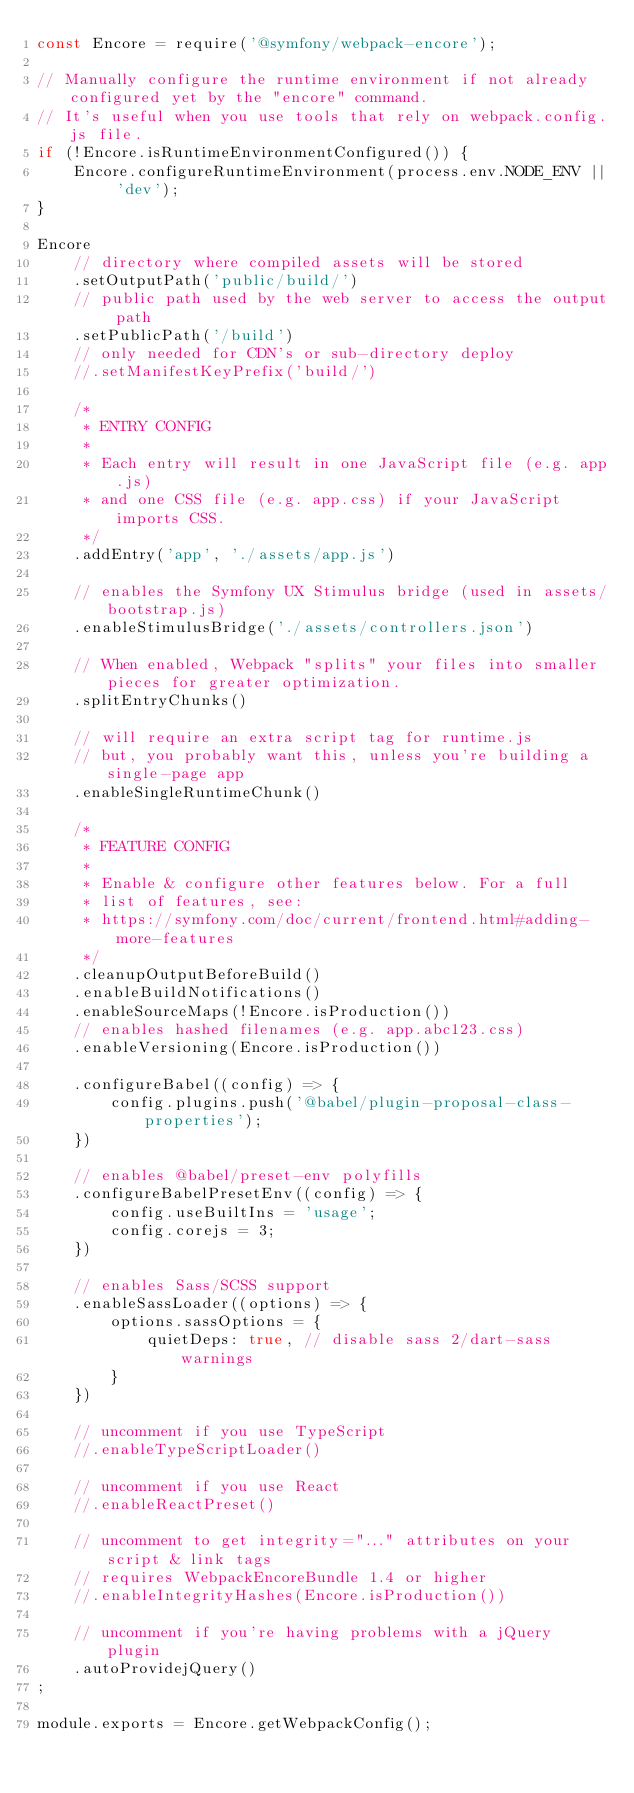Convert code to text. <code><loc_0><loc_0><loc_500><loc_500><_JavaScript_>const Encore = require('@symfony/webpack-encore');

// Manually configure the runtime environment if not already configured yet by the "encore" command.
// It's useful when you use tools that rely on webpack.config.js file.
if (!Encore.isRuntimeEnvironmentConfigured()) {
    Encore.configureRuntimeEnvironment(process.env.NODE_ENV || 'dev');
}

Encore
    // directory where compiled assets will be stored
    .setOutputPath('public/build/')
    // public path used by the web server to access the output path
    .setPublicPath('/build')
    // only needed for CDN's or sub-directory deploy
    //.setManifestKeyPrefix('build/')

    /*
     * ENTRY CONFIG
     *
     * Each entry will result in one JavaScript file (e.g. app.js)
     * and one CSS file (e.g. app.css) if your JavaScript imports CSS.
     */
    .addEntry('app', './assets/app.js')

    // enables the Symfony UX Stimulus bridge (used in assets/bootstrap.js)
    .enableStimulusBridge('./assets/controllers.json')

    // When enabled, Webpack "splits" your files into smaller pieces for greater optimization.
    .splitEntryChunks()

    // will require an extra script tag for runtime.js
    // but, you probably want this, unless you're building a single-page app
    .enableSingleRuntimeChunk()

    /*
     * FEATURE CONFIG
     *
     * Enable & configure other features below. For a full
     * list of features, see:
     * https://symfony.com/doc/current/frontend.html#adding-more-features
     */
    .cleanupOutputBeforeBuild()
    .enableBuildNotifications()
    .enableSourceMaps(!Encore.isProduction())
    // enables hashed filenames (e.g. app.abc123.css)
    .enableVersioning(Encore.isProduction())

    .configureBabel((config) => {
        config.plugins.push('@babel/plugin-proposal-class-properties');
    })

    // enables @babel/preset-env polyfills
    .configureBabelPresetEnv((config) => {
        config.useBuiltIns = 'usage';
        config.corejs = 3;
    })

    // enables Sass/SCSS support
    .enableSassLoader((options) => {
        options.sassOptions = {
            quietDeps: true, // disable sass 2/dart-sass warnings
        }
    })

    // uncomment if you use TypeScript
    //.enableTypeScriptLoader()

    // uncomment if you use React
    //.enableReactPreset()

    // uncomment to get integrity="..." attributes on your script & link tags
    // requires WebpackEncoreBundle 1.4 or higher
    //.enableIntegrityHashes(Encore.isProduction())

    // uncomment if you're having problems with a jQuery plugin
    .autoProvidejQuery()
;

module.exports = Encore.getWebpackConfig();
</code> 